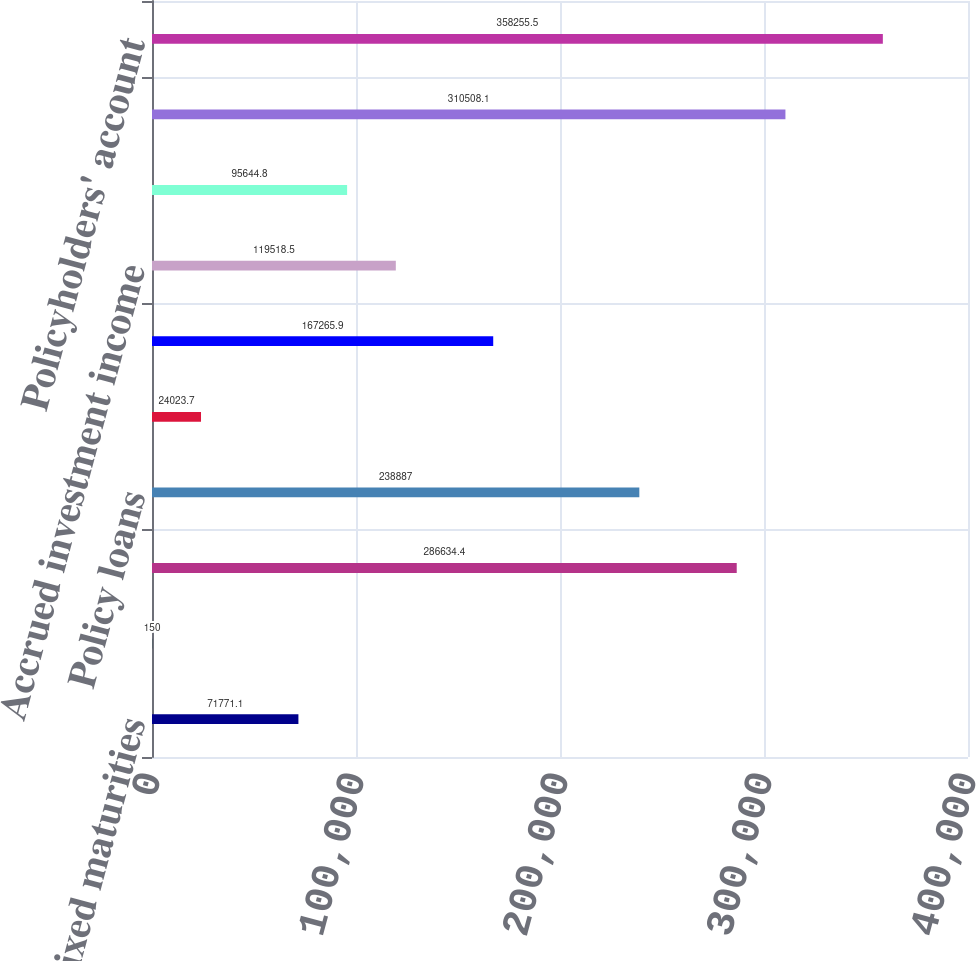Convert chart to OTSL. <chart><loc_0><loc_0><loc_500><loc_500><bar_chart><fcel>Fixed maturities<fcel>Trading account assets<fcel>Commercial mortgage and other<fcel>Policy loans<fcel>Short-term investments<fcel>Cash and cash equivalents<fcel>Accrued investment income<fcel>Other assets<fcel>Total assets<fcel>Policyholders' account<nl><fcel>71771.1<fcel>150<fcel>286634<fcel>238887<fcel>24023.7<fcel>167266<fcel>119518<fcel>95644.8<fcel>310508<fcel>358256<nl></chart> 